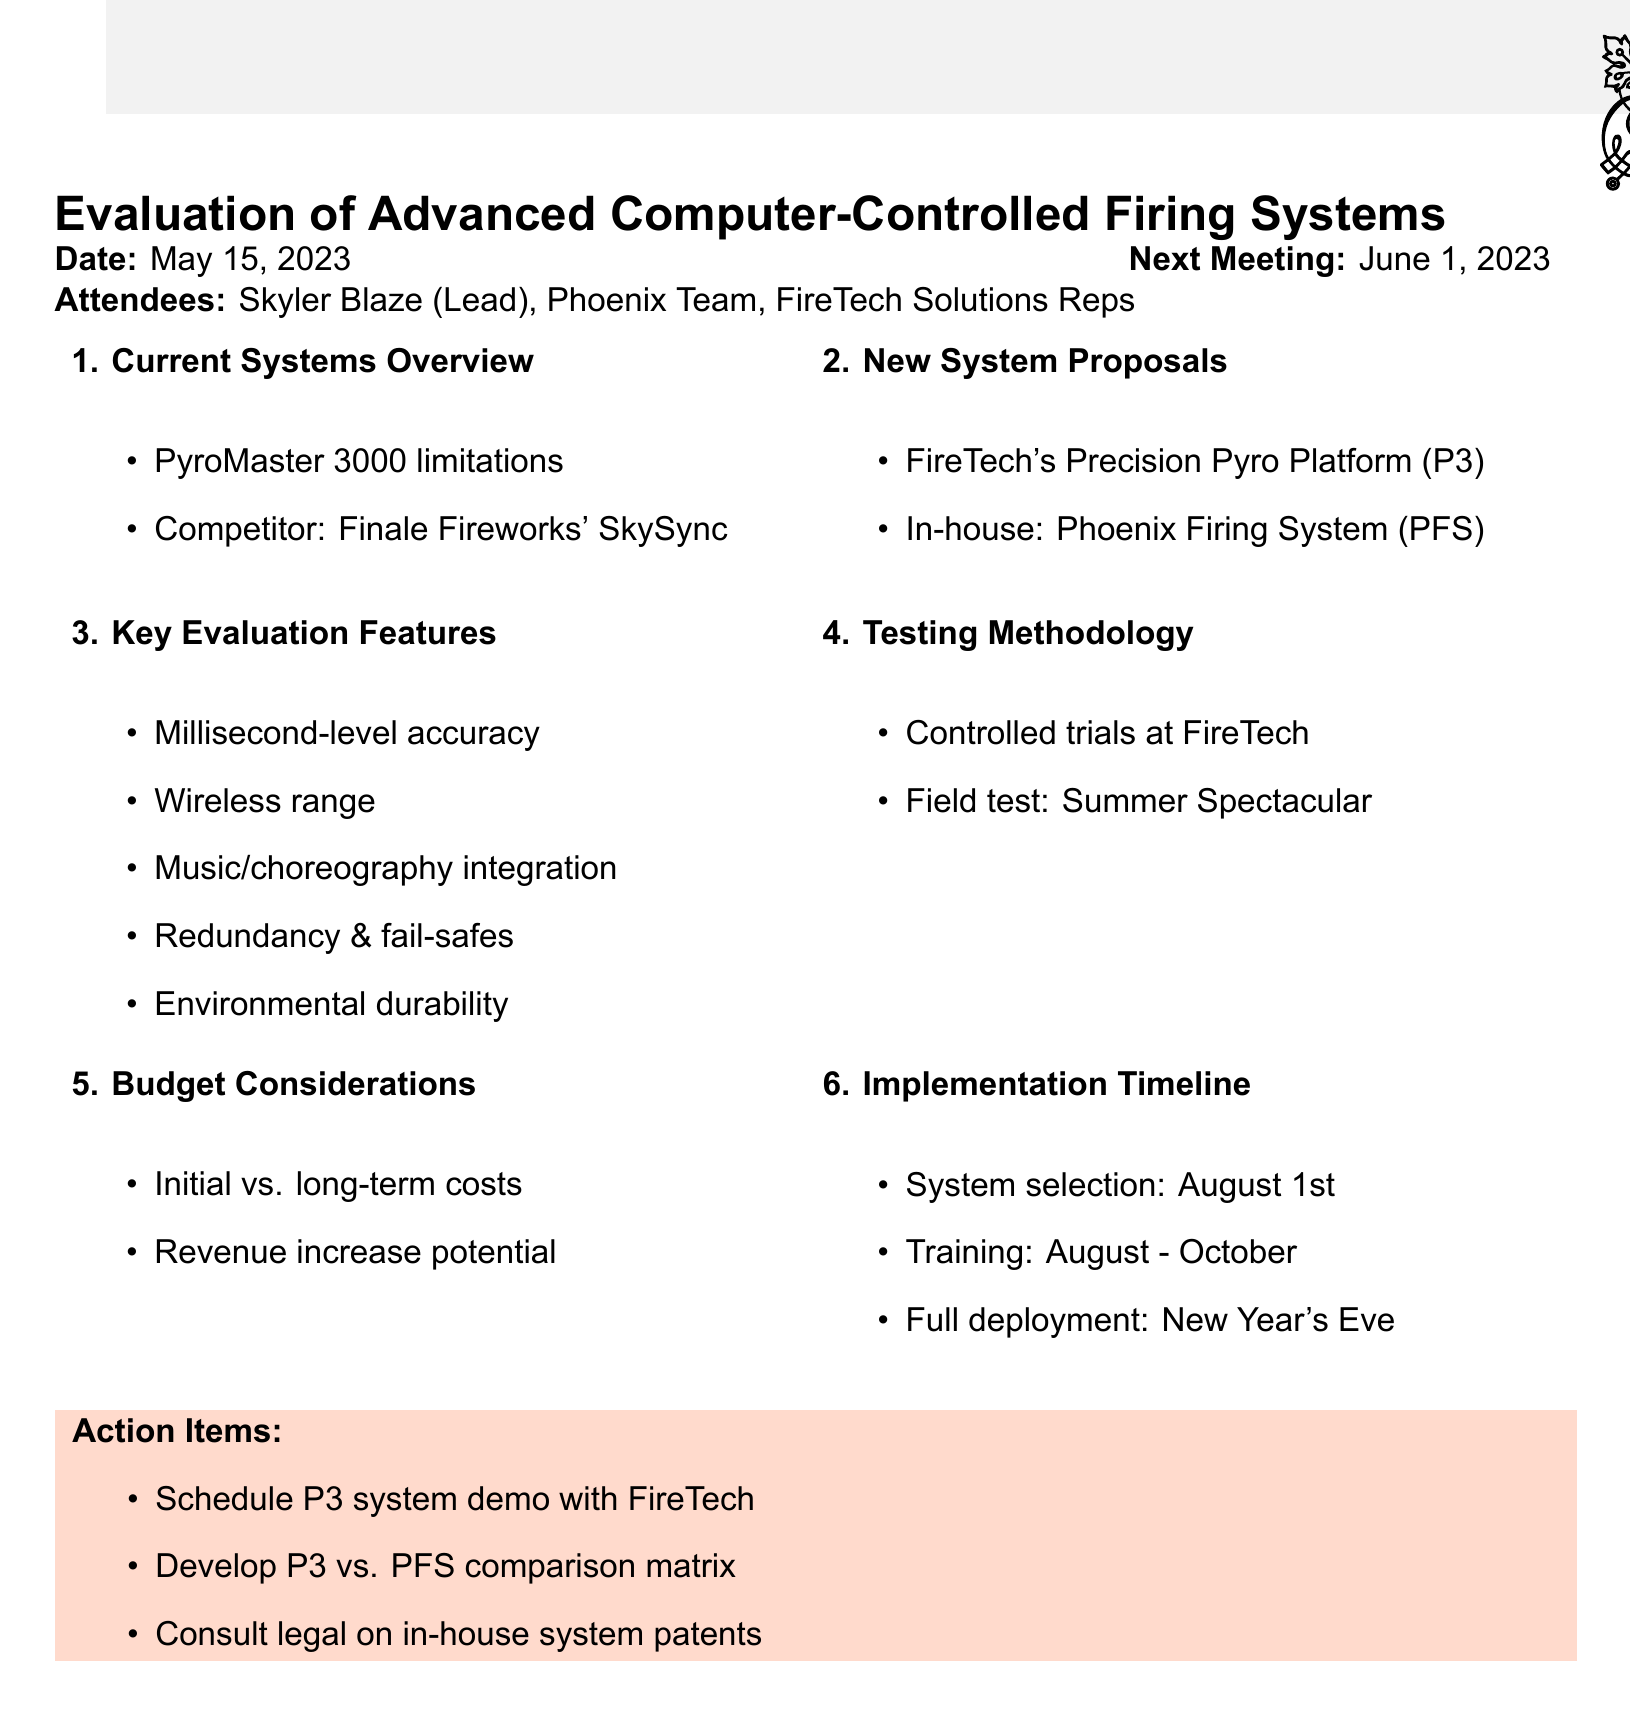what is the meeting title? The meeting title is stated at the beginning of the document.
Answer: Evaluation of Advanced Computer-Controlled Firing Systems for Multi-Launch Displays who attended the meeting? The attendees are listed under the attendees section of the document.
Answer: Skyler Blaze, Phoenix Fireworks Team, Representatives from FireTech Solutions what is the date of the next meeting? The date of the next meeting is mentioned at the end of the meeting details.
Answer: June 1, 2023 what is one limitation of the PyroMaster 3000? The limitations of the PyroMaster 3000 are outlined in the overview of current systems.
Answer: Not specified in the document how many key features for evaluation are listed? The number of key features for evaluation is found in the relevant section of the document.
Answer: Five what is the implementation timeline's system selection date? The implementation timeline specifies when the system selection should occur.
Answer: August 1st what are the action items from the meeting? The action items are listed at the end of the document under a specific section.
Answer: Schedule on-site demonstration of P3 system with FireTech Solutions, Develop detailed comparison matrix of P3 vs. PFS, Consult with legal team regarding potential patent issues for in-house system what is the purpose of the meeting? The purpose is inferred from the meeting title and agenda items discussed.
Answer: Evaluation of advanced firing systems what type of testing is planned for the upcoming Summer Spectacular event? The testing methodology outlines the types of tests that will be conducted.
Answer: Field testing 